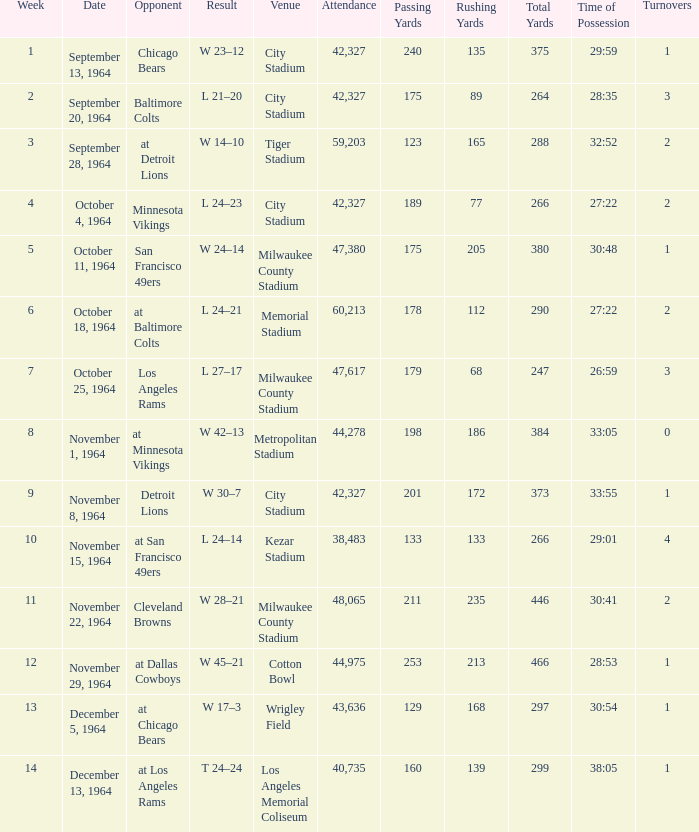What is the average attendance at a week 4 game? 42327.0. 